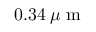<formula> <loc_0><loc_0><loc_500><loc_500>0 . 3 4 \, \mu m</formula> 